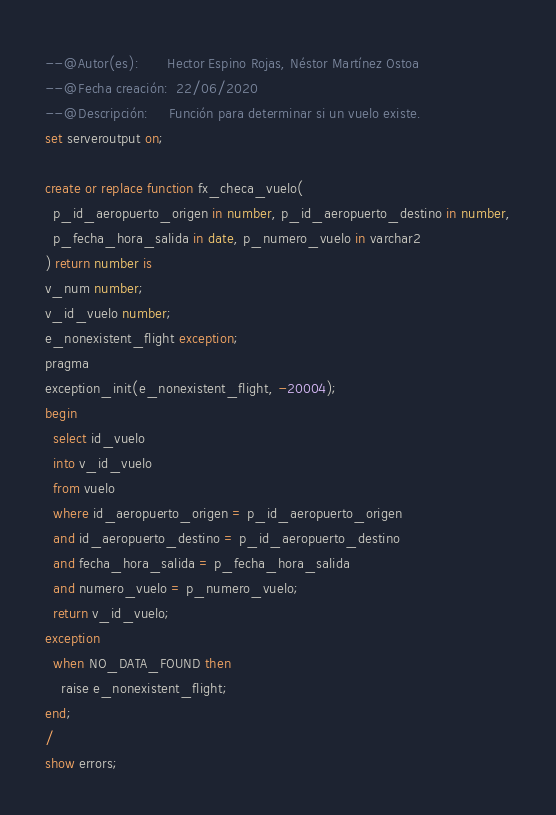<code> <loc_0><loc_0><loc_500><loc_500><_SQL_>--@Autor(es):       Hector Espino Rojas, Néstor Martínez Ostoa
--@Fecha creación:  22/06/2020
--@Descripción:     Función para determinar si un vuelo existe.
set serveroutput on;

create or replace function fx_checa_vuelo( 
  p_id_aeropuerto_origen in number, p_id_aeropuerto_destino in number,
  p_fecha_hora_salida in date, p_numero_vuelo in varchar2
) return number is
v_num number;
v_id_vuelo number;
e_nonexistent_flight exception;
pragma
exception_init(e_nonexistent_flight, -20004);
begin
  select id_vuelo
  into v_id_vuelo
  from vuelo
  where id_aeropuerto_origen = p_id_aeropuerto_origen
  and id_aeropuerto_destino = p_id_aeropuerto_destino
  and fecha_hora_salida = p_fecha_hora_salida
  and numero_vuelo = p_numero_vuelo;
  return v_id_vuelo;
exception
  when NO_DATA_FOUND then
    raise e_nonexistent_flight;
end;
/ 
show errors;</code> 